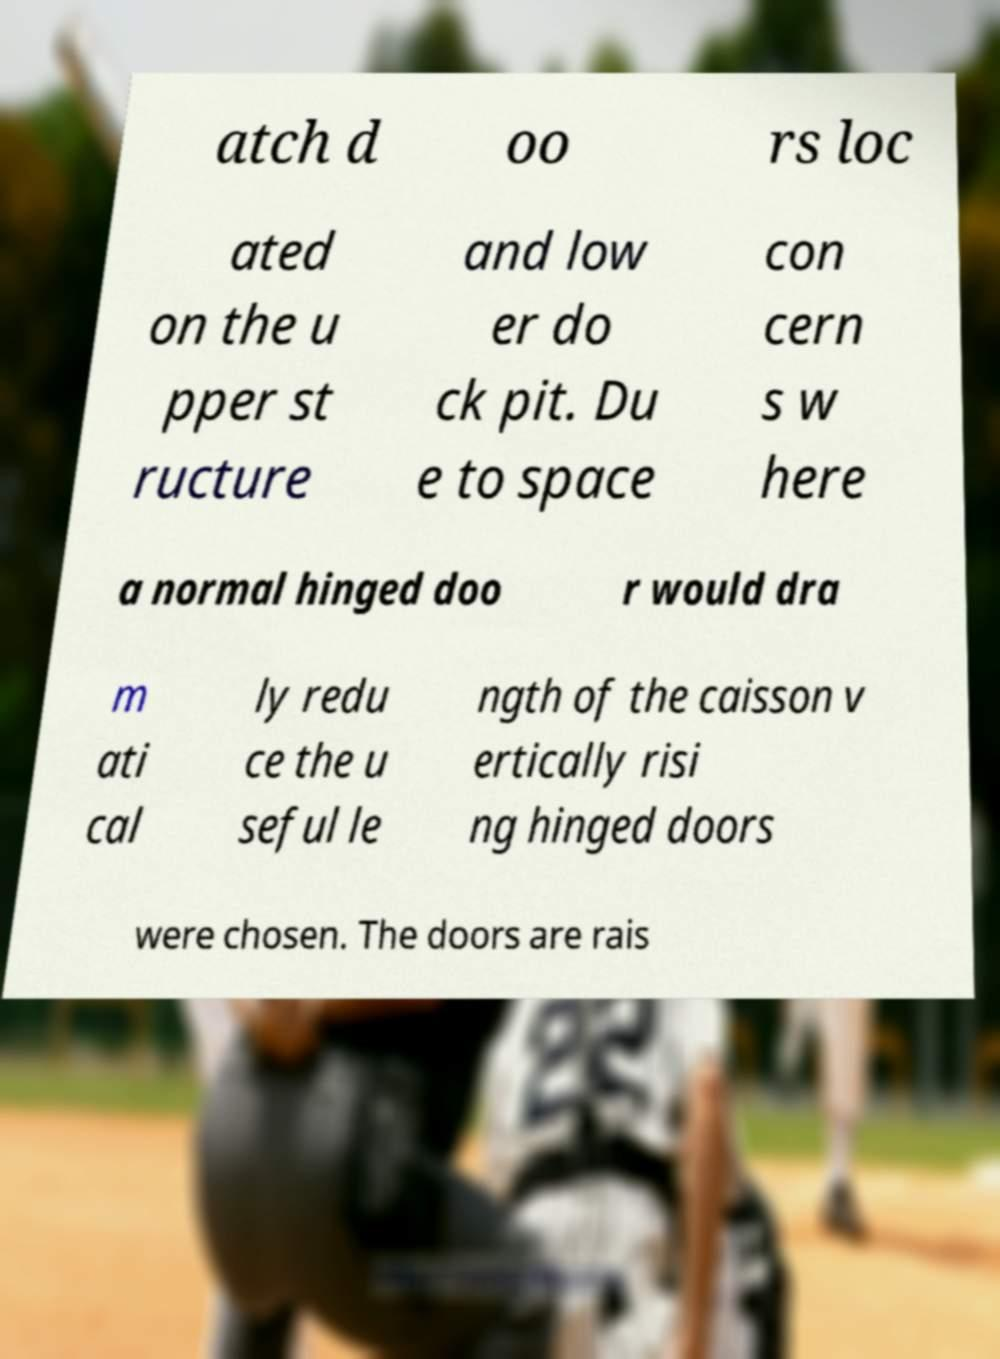Could you assist in decoding the text presented in this image and type it out clearly? atch d oo rs loc ated on the u pper st ructure and low er do ck pit. Du e to space con cern s w here a normal hinged doo r would dra m ati cal ly redu ce the u seful le ngth of the caisson v ertically risi ng hinged doors were chosen. The doors are rais 